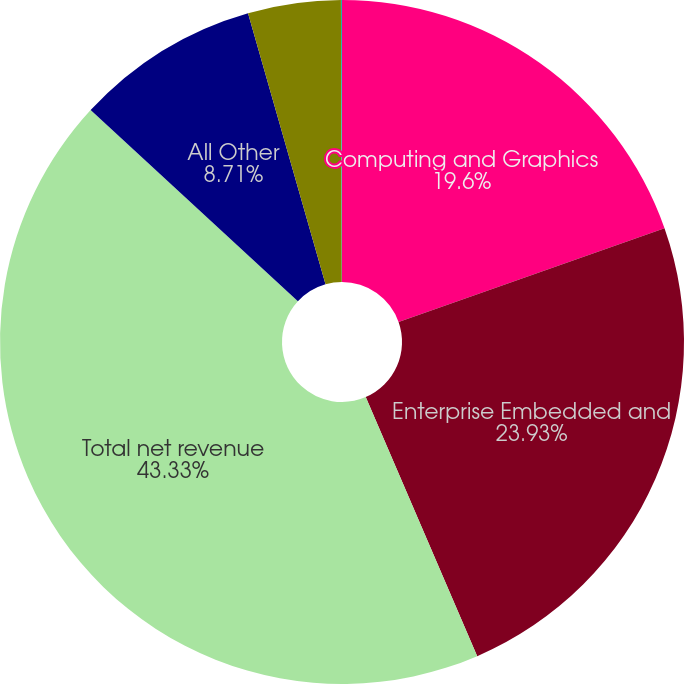<chart> <loc_0><loc_0><loc_500><loc_500><pie_chart><fcel>Computing and Graphics<fcel>Enterprise Embedded and<fcel>Total net revenue<fcel>All Other<fcel>Interest expense<fcel>Other income (expense) net<nl><fcel>19.6%<fcel>23.93%<fcel>43.33%<fcel>8.71%<fcel>4.38%<fcel>0.05%<nl></chart> 